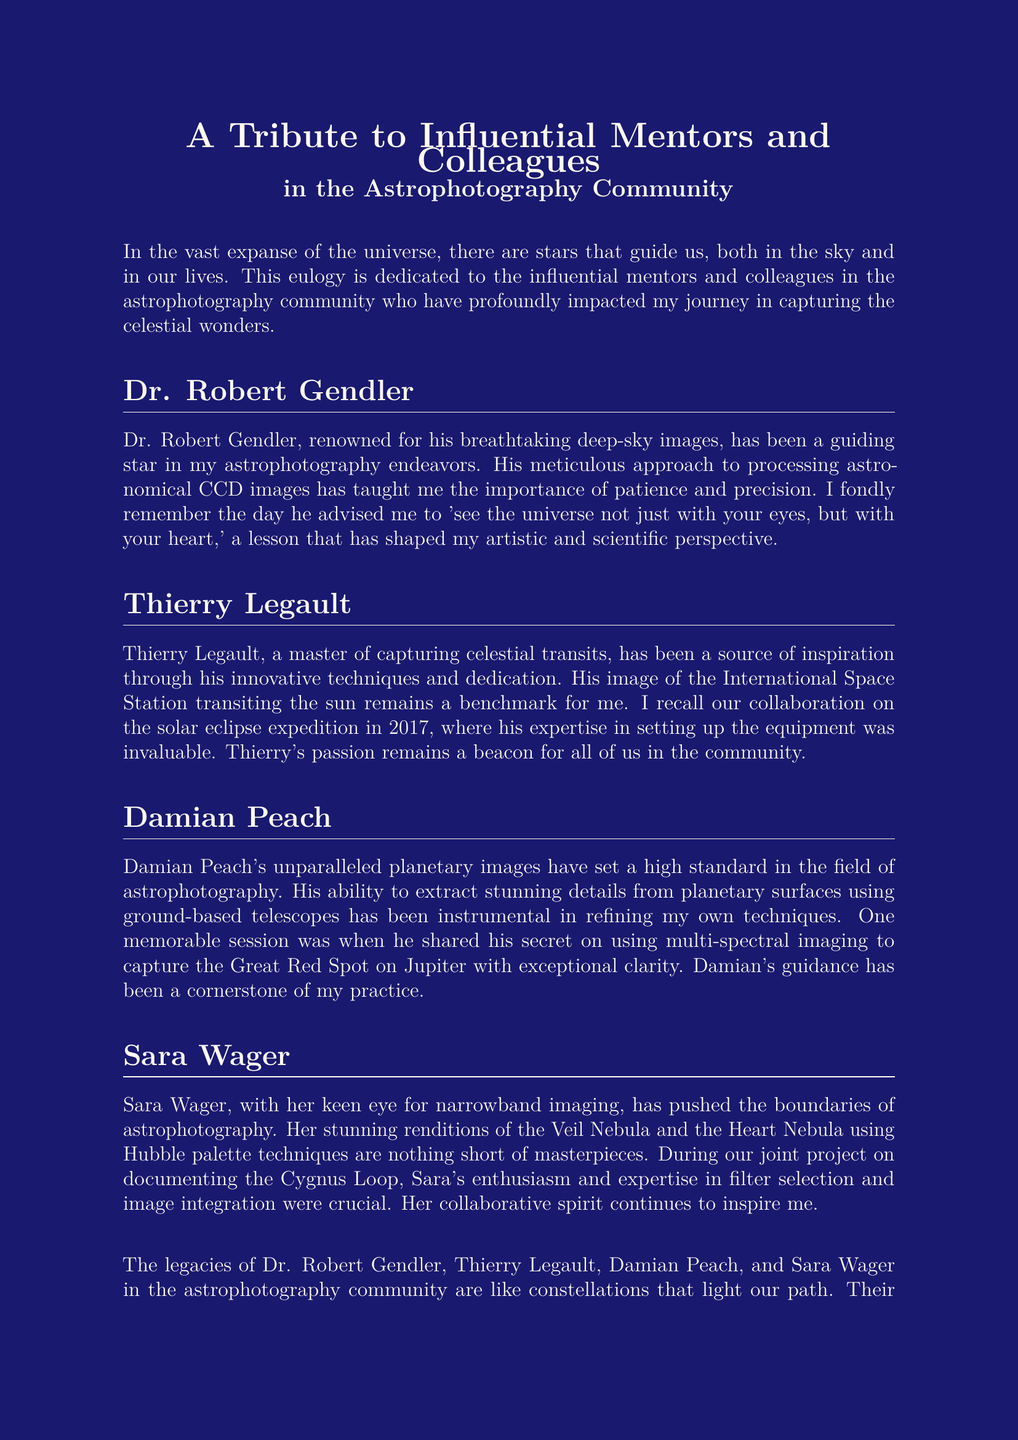What is the title of the document? The title is found at the beginning of the document and reflects its main theme.
Answer: A Tribute to Influential Mentors and Colleagues in the Astrophotography Community Who is mentioned as a master of capturing celestial transits? This individual is recognized for their innovative techniques in astrophotography and is noted for specific works.
Answer: Thierry Legault Which astronomical event did the author collaborate on with Thierry Legault? The document states a specific event where both individuals worked together on a project.
Answer: Solar eclipse expedition in 2017 What notable image is Dr. Robert Gendler known for? The document highlights his work in capturing deep-sky images, which is attributed to his expertise.
Answer: Breathtaking deep-sky images What imaging technique did Damian Peach share? The document refers to a particular method he used that was impactful for the author's photography.
Answer: Multi-spectral imaging Which nebulae are mentioned concerning Sara Wager's work? The document lists the specific targets of Sara Wager's astrophotography that emphasize her skills.
Answer: Veil Nebula and Heart Nebula What is the overarching theme of the document? The document serves to reflect on the collective contributions of mentors and colleagues in one specific community.
Answer: Tribute What is highlighted as a lesson learned from Dr. Robert Gendler? This lesson is mentioned as a profound influence on the author's approach to astrophotography.
Answer: See the universe not just with your eyes, but with your heart 